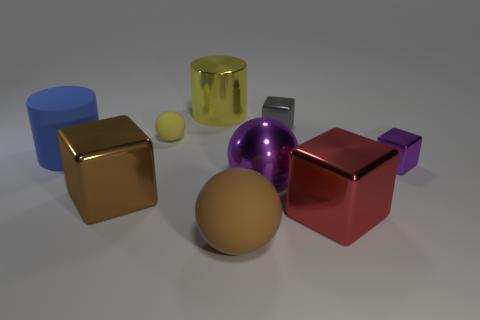Subtract all purple shiny cubes. How many cubes are left? 3 Subtract all purple spheres. How many spheres are left? 2 Subtract all cubes. How many objects are left? 5 Subtract 1 yellow cylinders. How many objects are left? 8 Subtract 1 balls. How many balls are left? 2 Subtract all purple cylinders. Subtract all yellow blocks. How many cylinders are left? 2 Subtract all gray balls. How many yellow cylinders are left? 1 Subtract all tiny blue metal blocks. Subtract all matte balls. How many objects are left? 7 Add 7 small purple blocks. How many small purple blocks are left? 8 Add 9 tiny cyan rubber cylinders. How many tiny cyan rubber cylinders exist? 9 